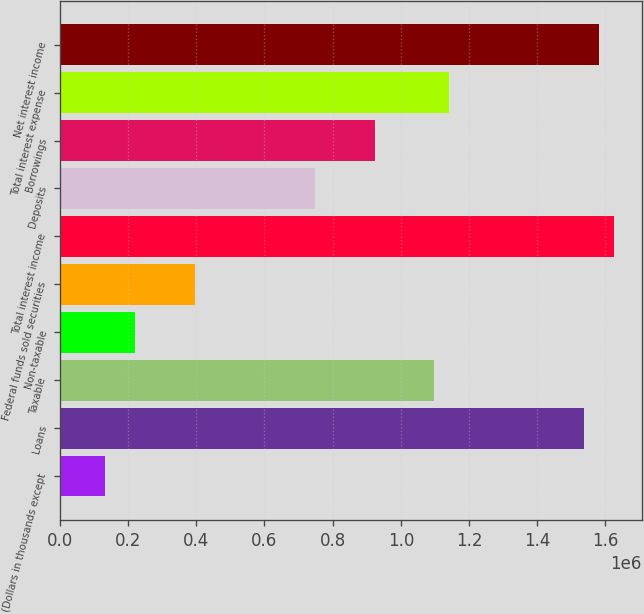Convert chart. <chart><loc_0><loc_0><loc_500><loc_500><bar_chart><fcel>(Dollars in thousands except<fcel>Loans<fcel>Taxable<fcel>Non-taxable<fcel>Federal funds sold securities<fcel>Total interest income<fcel>Deposits<fcel>Borrowings<fcel>Total interest expense<fcel>Net interest income<nl><fcel>131849<fcel>1.53821e+06<fcel>1.09872e+06<fcel>219747<fcel>395542<fcel>1.62611e+06<fcel>747133<fcel>922929<fcel>1.14267e+06<fcel>1.58216e+06<nl></chart> 